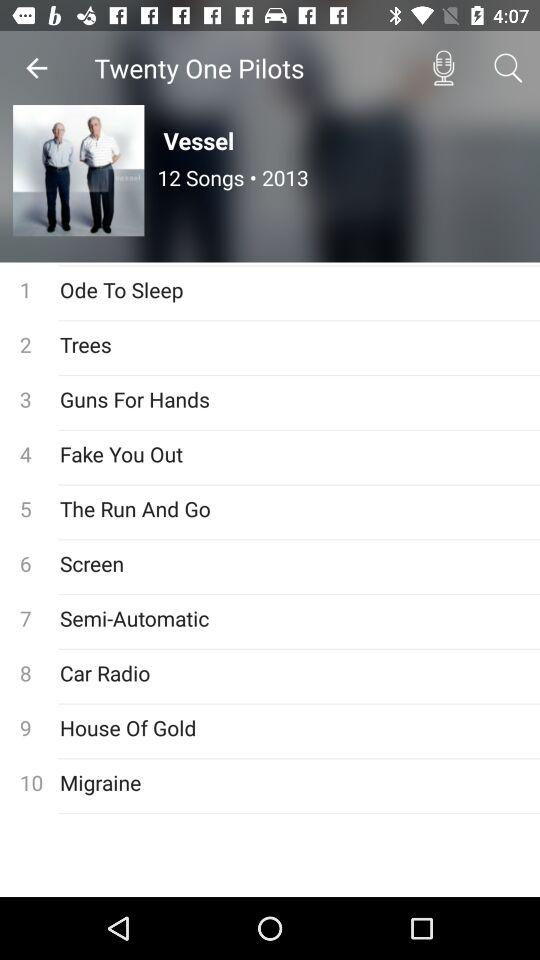What are the different songs available? The different songs available are "Ode To Sleep", "Trees", "Guns For Hands", "Fake You Out", "The Run And Go", "Screen", "Semi-Automatic", "Car Radio", "House Of Gold" and "Migraine". 